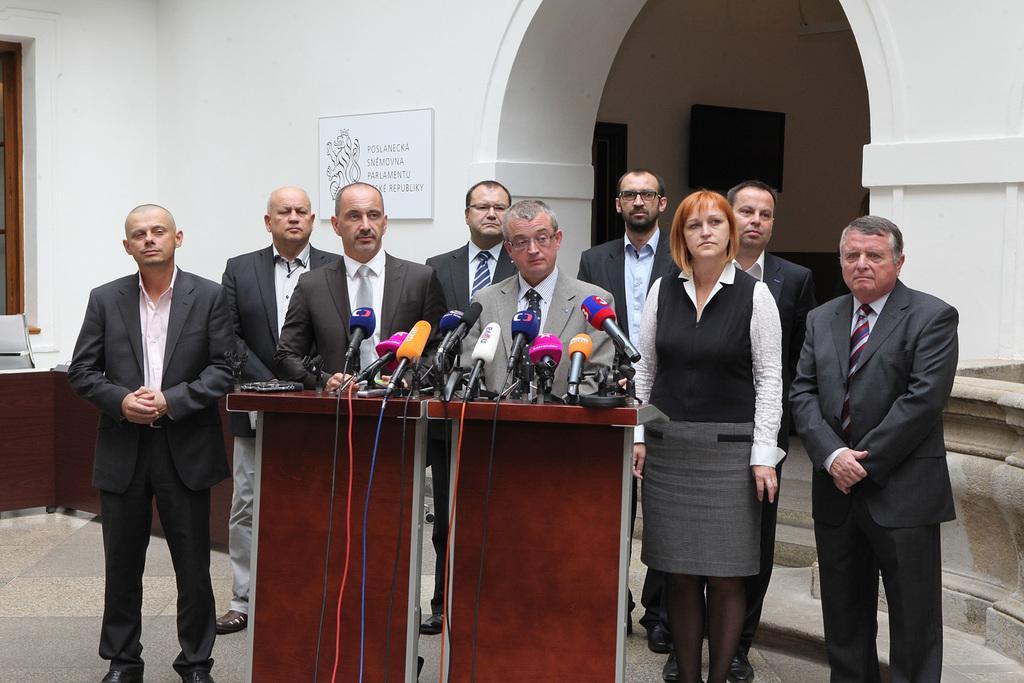Describe this image in one or two sentences. In the center of the image we can see people standing, before them there is a table and we can see mics placed on the table. In the background there is a television and a board placed on the wall. On the left there is a window. 